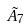<formula> <loc_0><loc_0><loc_500><loc_500>\tilde { A } _ { 7 }</formula> 